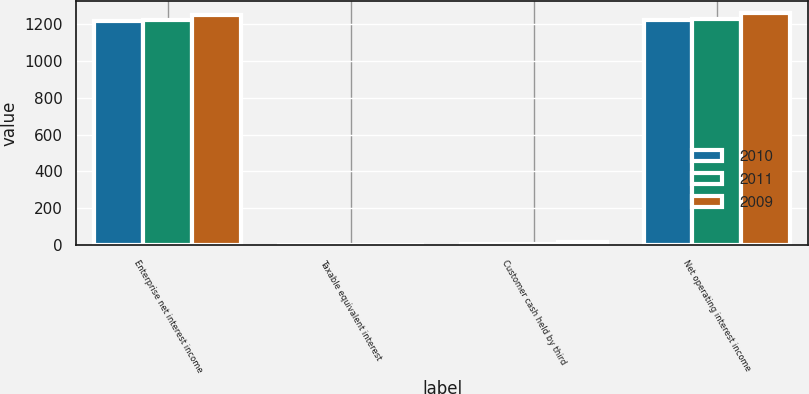<chart> <loc_0><loc_0><loc_500><loc_500><stacked_bar_chart><ecel><fcel>Enterprise net interest income<fcel>Taxable equivalent interest<fcel>Customer cash held by third<fcel>Net operating interest income<nl><fcel>2010<fcel>1213.9<fcel>1.2<fcel>7.3<fcel>1220<nl><fcel>2011<fcel>1219.1<fcel>1.2<fcel>8.4<fcel>1226.3<nl><fcel>2009<fcel>1247.2<fcel>2.1<fcel>15.5<fcel>1260.6<nl></chart> 